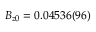Convert formula to latex. <formula><loc_0><loc_0><loc_500><loc_500>B _ { z 0 } = 0 . 0 4 5 3 6 ( 9 6 )</formula> 